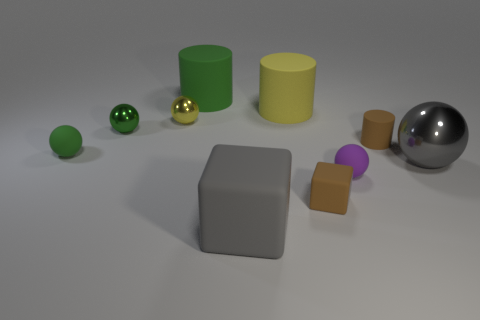Subtract 1 cylinders. How many cylinders are left? 2 Subtract all purple spheres. How many spheres are left? 4 Subtract all purple balls. How many balls are left? 4 Subtract all red balls. Subtract all purple cubes. How many balls are left? 5 Subtract all cubes. How many objects are left? 8 Subtract all big yellow rubber cylinders. Subtract all brown things. How many objects are left? 7 Add 7 tiny green shiny balls. How many tiny green shiny balls are left? 8 Add 10 yellow metal cylinders. How many yellow metal cylinders exist? 10 Subtract 0 red blocks. How many objects are left? 10 